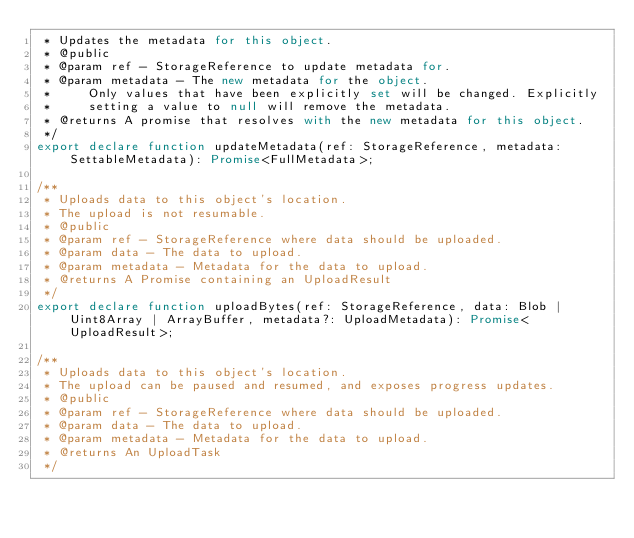Convert code to text. <code><loc_0><loc_0><loc_500><loc_500><_TypeScript_> * Updates the metadata for this object.
 * @public
 * @param ref - StorageReference to update metadata for.
 * @param metadata - The new metadata for the object.
 *     Only values that have been explicitly set will be changed. Explicitly
 *     setting a value to null will remove the metadata.
 * @returns A promise that resolves with the new metadata for this object.
 */
export declare function updateMetadata(ref: StorageReference, metadata: SettableMetadata): Promise<FullMetadata>;

/**
 * Uploads data to this object's location.
 * The upload is not resumable.
 * @public
 * @param ref - StorageReference where data should be uploaded.
 * @param data - The data to upload.
 * @param metadata - Metadata for the data to upload.
 * @returns A Promise containing an UploadResult
 */
export declare function uploadBytes(ref: StorageReference, data: Blob | Uint8Array | ArrayBuffer, metadata?: UploadMetadata): Promise<UploadResult>;

/**
 * Uploads data to this object's location.
 * The upload can be paused and resumed, and exposes progress updates.
 * @public
 * @param ref - StorageReference where data should be uploaded.
 * @param data - The data to upload.
 * @param metadata - Metadata for the data to upload.
 * @returns An UploadTask
 */</code> 